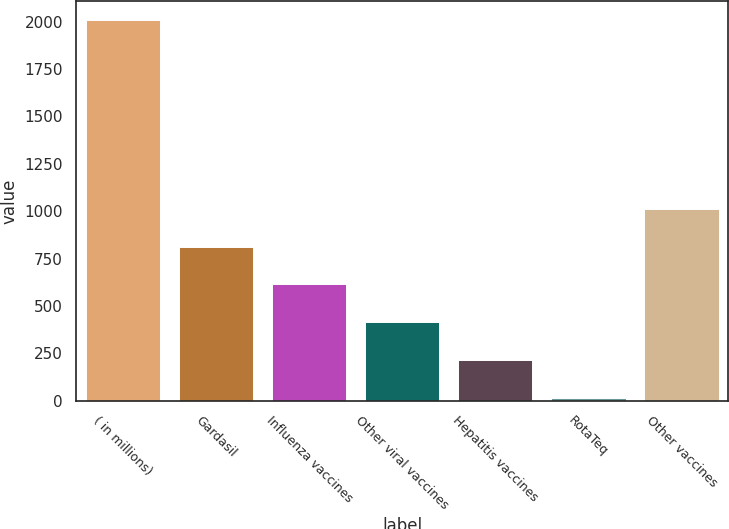Convert chart. <chart><loc_0><loc_0><loc_500><loc_500><bar_chart><fcel>( in millions)<fcel>Gardasil<fcel>Influenza vaccines<fcel>Other viral vaccines<fcel>Hepatitis vaccines<fcel>RotaTeq<fcel>Other vaccines<nl><fcel>2007<fcel>812.22<fcel>613.09<fcel>413.96<fcel>214.83<fcel>15.7<fcel>1011.35<nl></chart> 